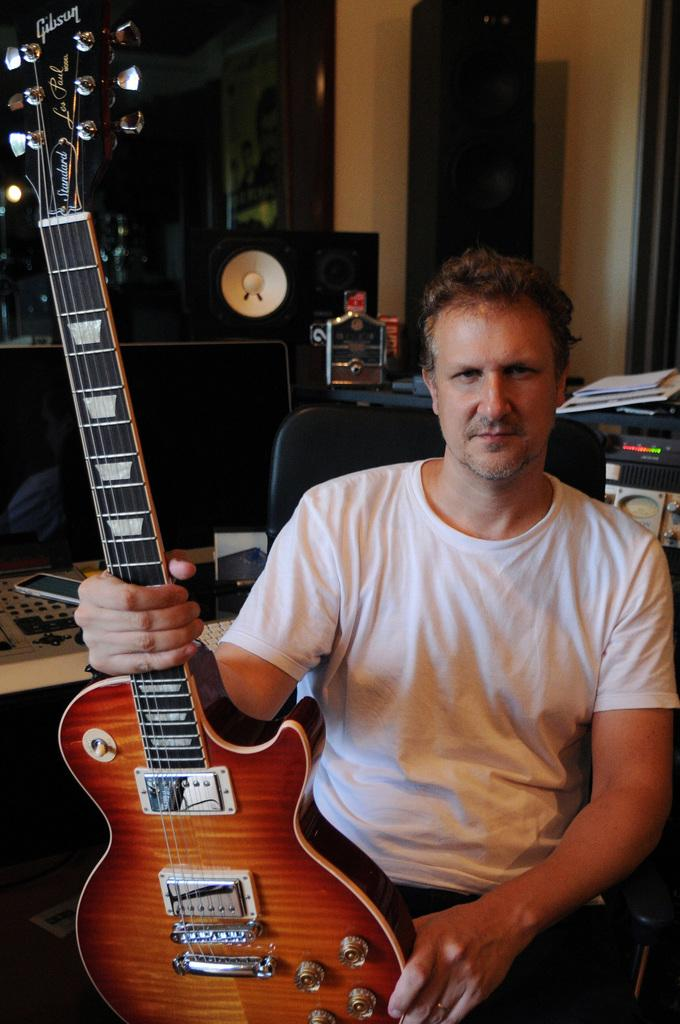What is the man in the image doing? The man is sitting in the image and holding a guitar. What objects can be seen in the background of the image? There is a phone, a television, and a speaker in the background of the image. What is the man wearing in the image? The man is wearing a white t-shirt in the image. How does the man in the image attract the attention of the light? There is no mention of light in the image, and the man is not interacting with any light source. 